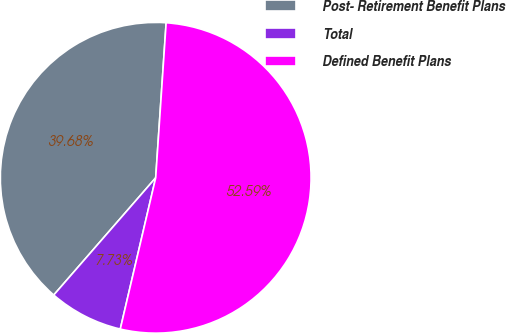<chart> <loc_0><loc_0><loc_500><loc_500><pie_chart><fcel>Post- Retirement Benefit Plans<fcel>Total<fcel>Defined Benefit Plans<nl><fcel>39.68%<fcel>7.73%<fcel>52.59%<nl></chart> 